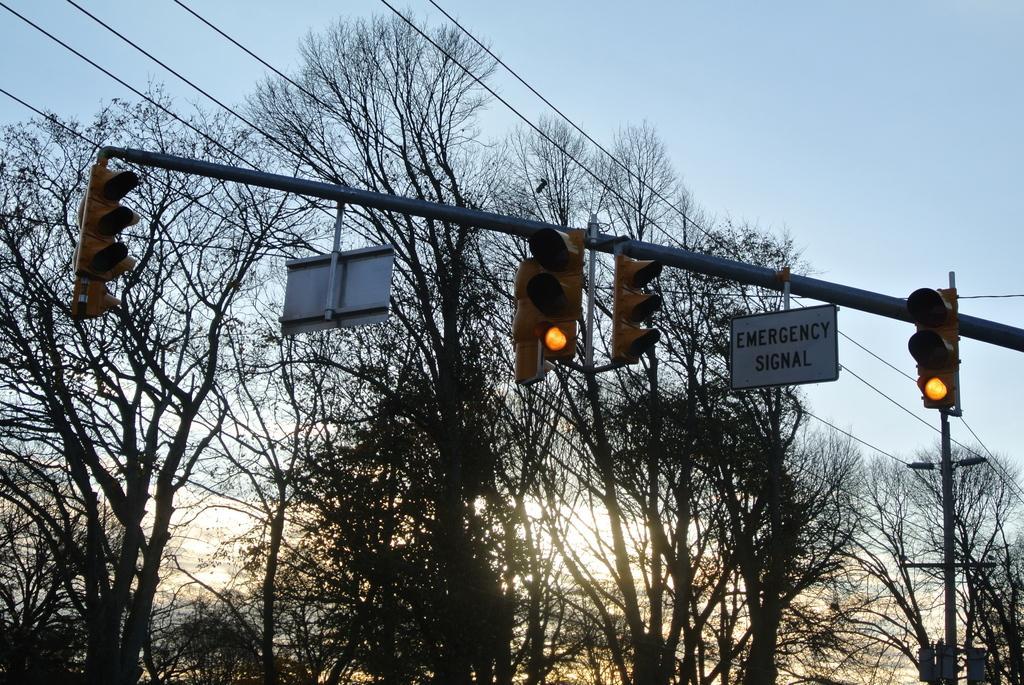Can you describe this image briefly? in the center of the picture there are signal lights and cable wires. In the background there are trees and a current pole. Sky is clear. It is sunset time. 